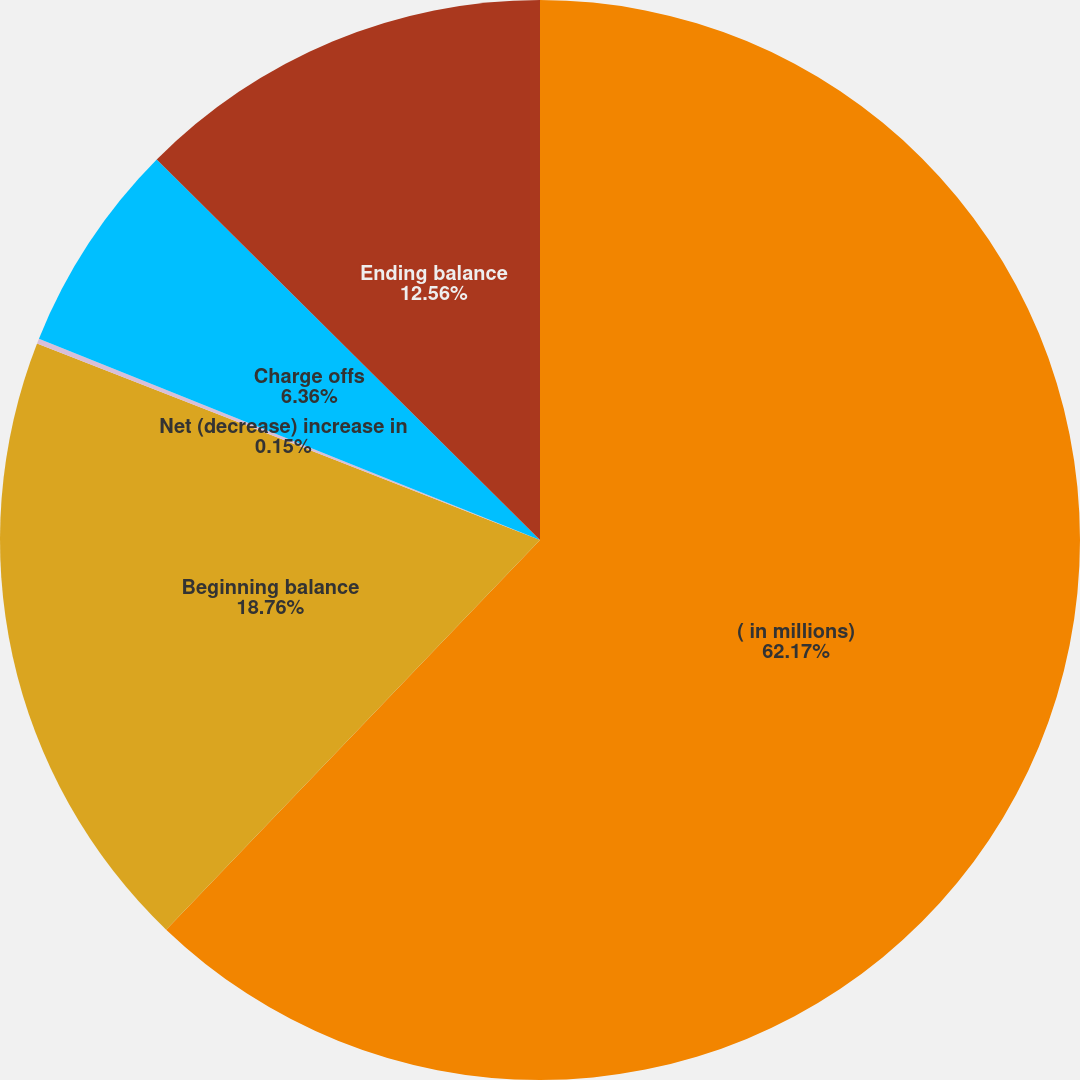Convert chart to OTSL. <chart><loc_0><loc_0><loc_500><loc_500><pie_chart><fcel>( in millions)<fcel>Beginning balance<fcel>Net (decrease) increase in<fcel>Charge offs<fcel>Ending balance<nl><fcel>62.17%<fcel>18.76%<fcel>0.15%<fcel>6.36%<fcel>12.56%<nl></chart> 